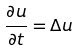<formula> <loc_0><loc_0><loc_500><loc_500>\frac { \partial u } { \partial t } = \Delta u</formula> 